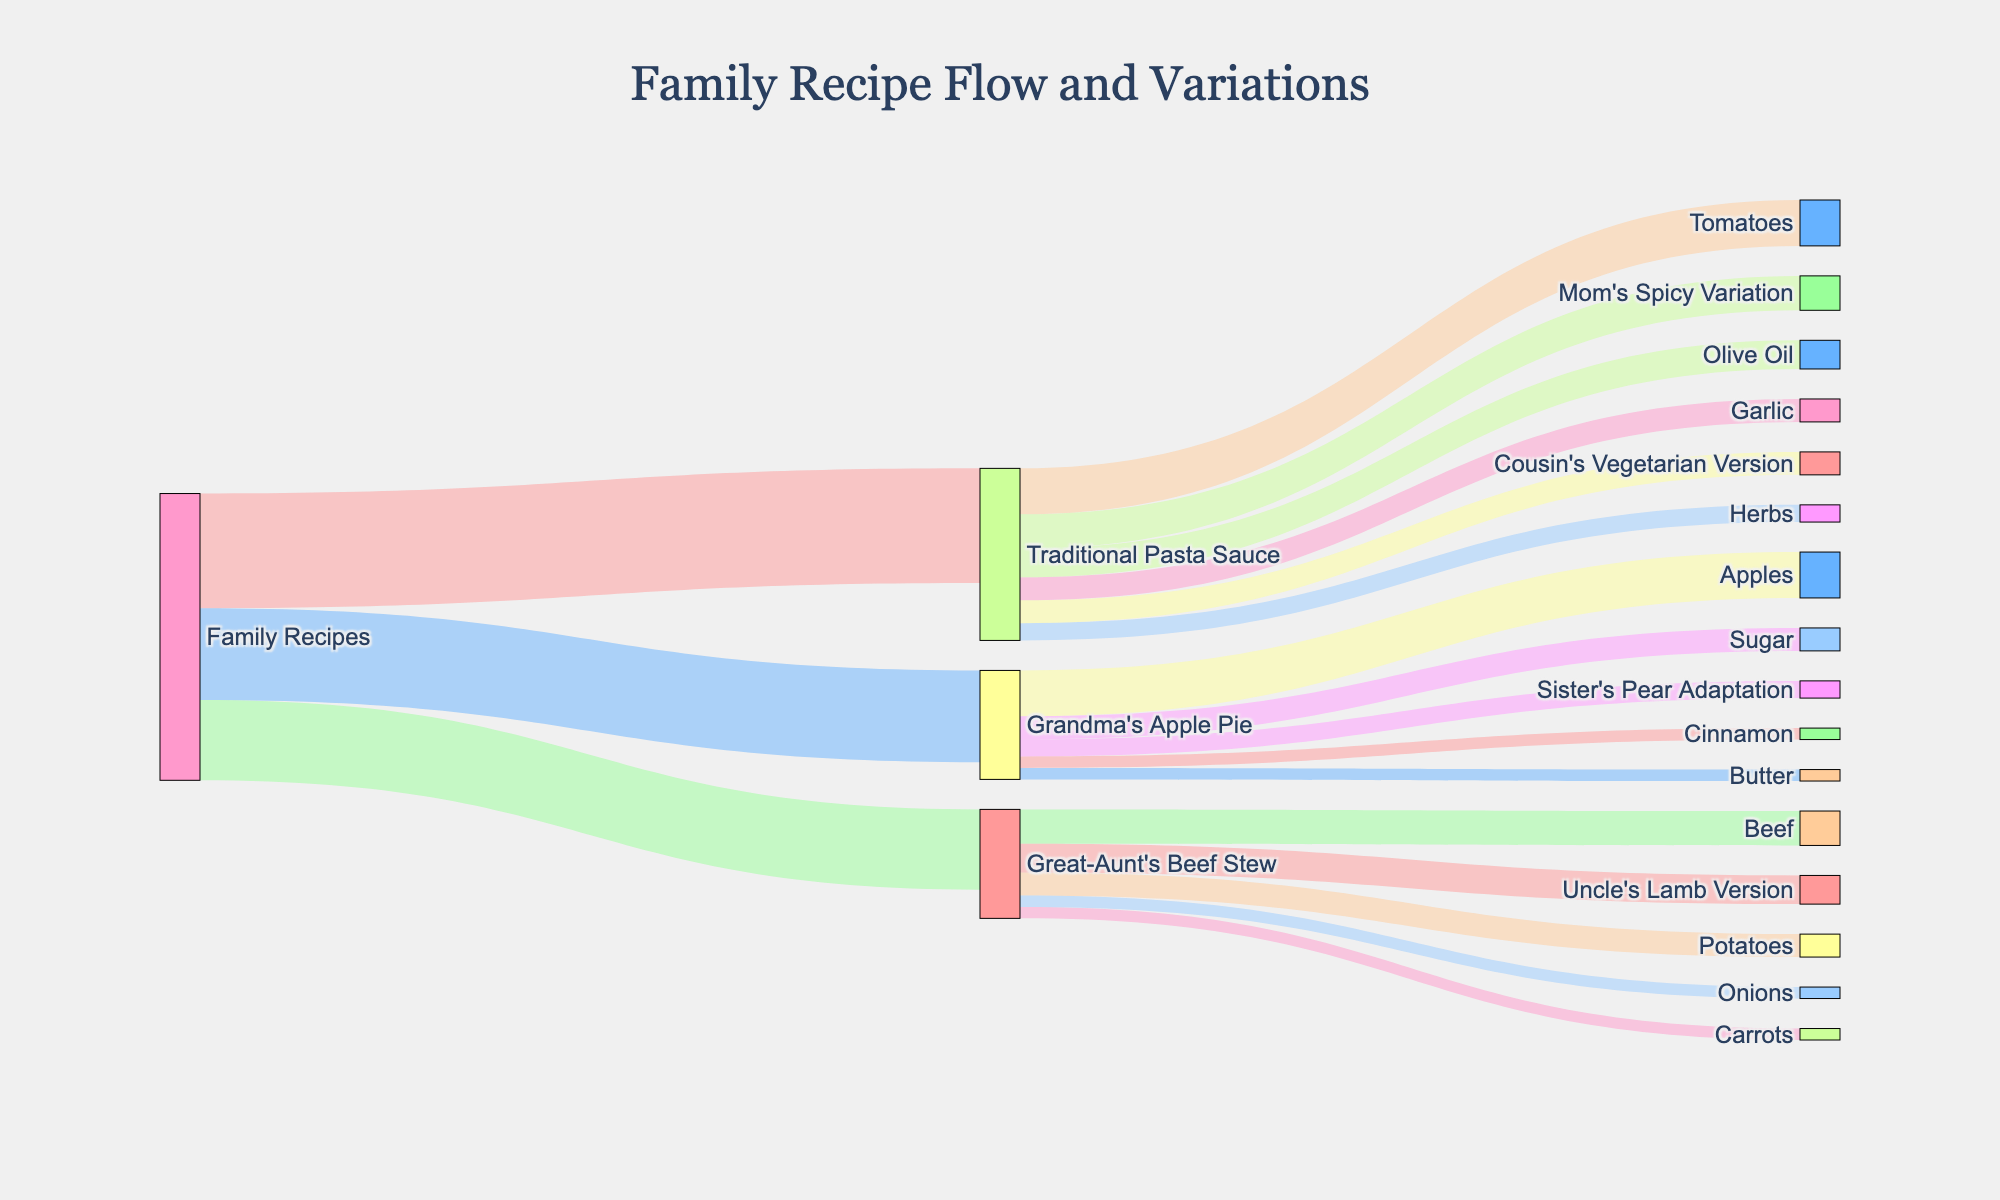What is the title of the Sankey Diagram? The title is located at the top-center of the diagram, displaying the main theme or subject of the figure.
Answer: Family Recipe Flow and Variations Which recipe has the highest flow from Family Recipes? To determine this, look at the width of the connections originating from Family Recipes and identify the widest one.
Answer: Traditional Pasta Sauce How many main recipes are included under Family Recipes? Check the number of distinct nodes directly connected to Family Recipes.
Answer: 3 Which ingredient flow in Traditional Pasta Sauce has the smallest value? Observe the flows coming out of Traditional Pasta Sauce and identify the one with the thinnest line.
Answer: Herbs How much total value is attributed to Mom's Spicy Variation and Cousin's Vegetarian Version combined? Sum the values of Mom's Spicy Variation and Cousin's Vegetarian Version connected to Traditional Pasta Sauce (30 + 20).
Answer: 50 Which recipe has the most variations derived from it? Count the number of distinct nodes connected to each original recipe's flow from Family Recipes.
Answer: Traditional Pasta Sauce Is the total value of the ingredients in Grandma's Apple Pie greater than those in Great-Aunt's Beef Stew? Sum the values connected to each recipe to compare: Grandma's Apple Pie (40 + 20 + 10 + 10 = 80) versus Great-Aunt's Beef Stew (30 + 20 + 10 + 10 = 70).
Answer: Yes Which variation has the highest value among the recipe variations listed? Identify the variation with the largest value connected to its original recipe.
Answer: Uncle's Lamb Version Compare the ingredient values of Garlic in Traditional Pasta Sauce versus Sugar in Grandma's Apple Pie. Which has a greater value? Check the value of each ingredient in their respective flows: Garlic (20) and Sugar (20).
Answer: Equal What is the combined value of all recipes and variations under Family Recipes? Sum the values of all nodes directly connected to Family Recipes (100 + 80 + 70 + 30 + 20 + 15 + 25).
Answer: 340 